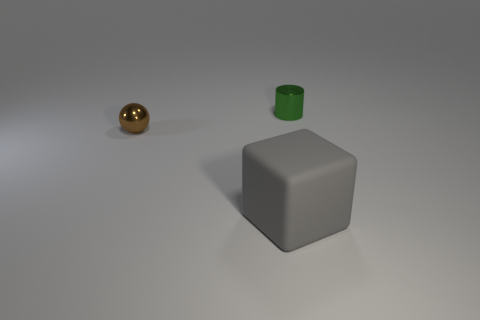Add 3 gray rubber blocks. How many objects exist? 6 Subtract all purple spheres. Subtract all gray cubes. How many spheres are left? 1 Subtract all spheres. How many objects are left? 2 Add 3 big gray blocks. How many big gray blocks are left? 4 Add 2 big brown rubber objects. How many big brown rubber objects exist? 2 Subtract 0 yellow balls. How many objects are left? 3 Subtract all shiny balls. Subtract all green cylinders. How many objects are left? 1 